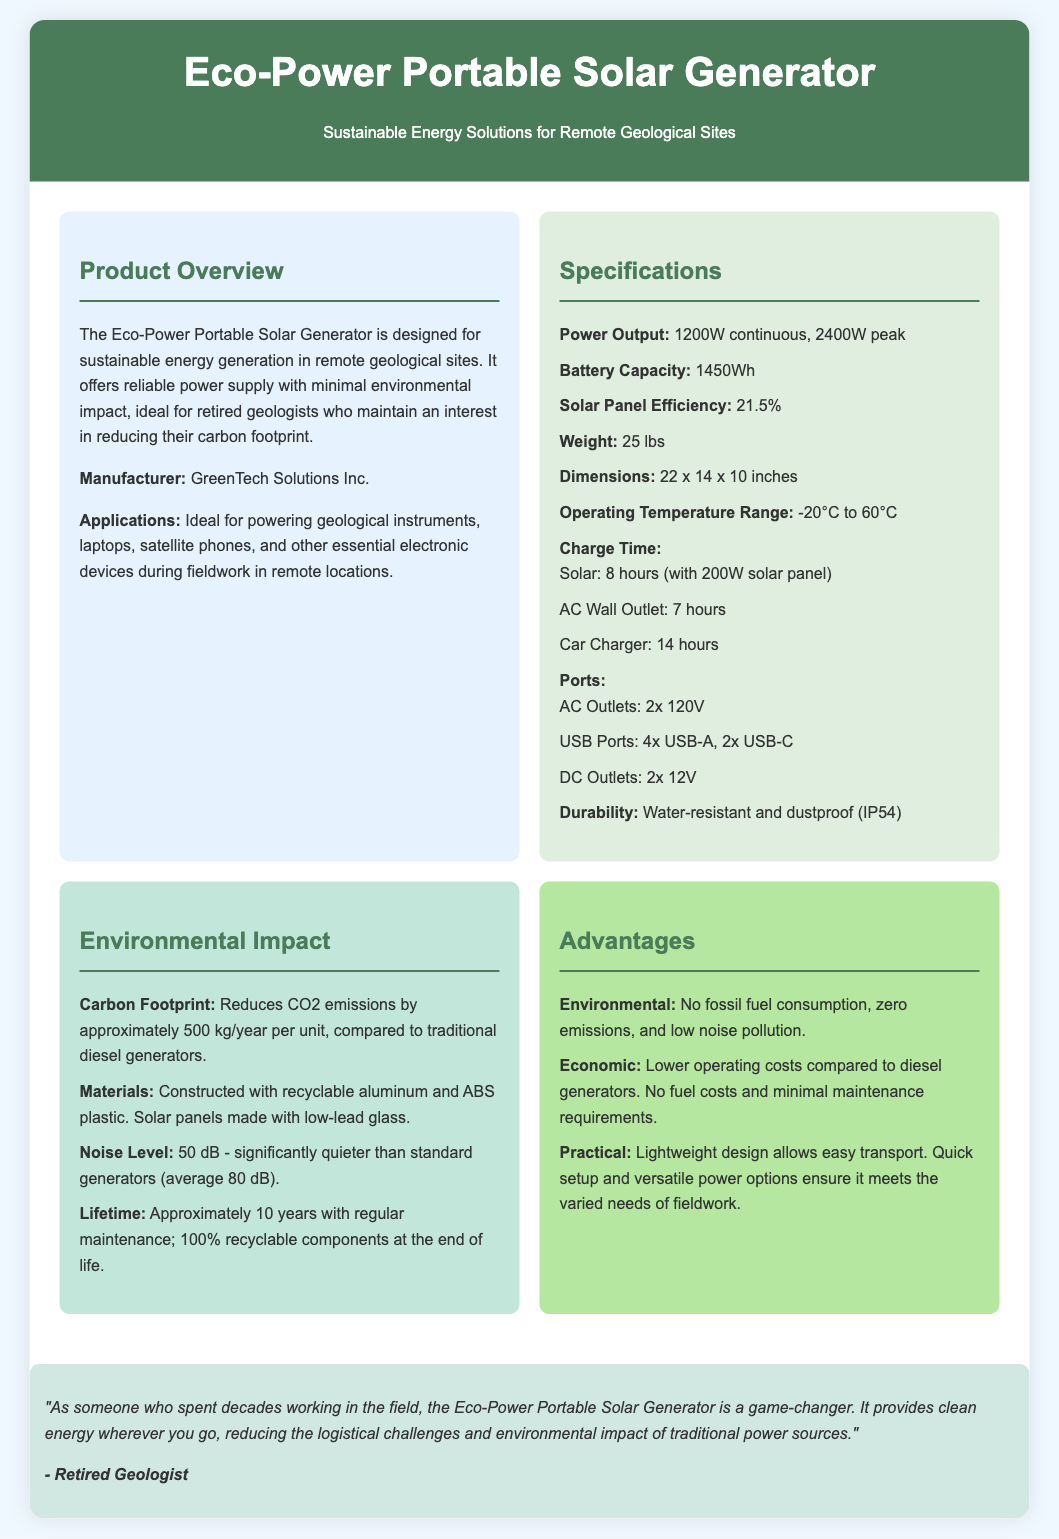What is the power output of the generator? The power output is specified as 1200W continuous and 2400W peak in the document.
Answer: 1200W continuous, 2400W peak What is the battery capacity? The battery capacity is explicitly mentioned in the specifications section of the document.
Answer: 1450Wh What type of materials are used in construction? The materials used in the construction are listed under the environmental impact section, describing what they are made from.
Answer: Recyclable aluminum and ABS plastic How much CO2 emissions does it reduce per year? The reduction of CO2 emissions is stated in the environmental impact section, providing a specific amount.
Answer: Approximately 500 kg/year What is the noise level of the generator? The noise level is provided in the environmental impact section, indicating how quiet it is compared to standard generators.
Answer: 50 dB What are the ports available on the generator? The available ports are specified in the specifications section, listing all the types of connections.
Answer: 2x 120V AC Outlets, 4x USB-A, 2x USB-C, 2x 12V DC Outlets What is the warranty period implied by the lifetime of the generator? The lifetime of approximately 10 years suggests a warranty period usually associated with such products.
Answer: Approximately 10 years What advantage is mentioned regarding economic benefits? The economic benefits, specifically mentioned in the advantages section, highlight a specific aspect of cost savings.
Answer: Lower operating costs compared to diesel generators 